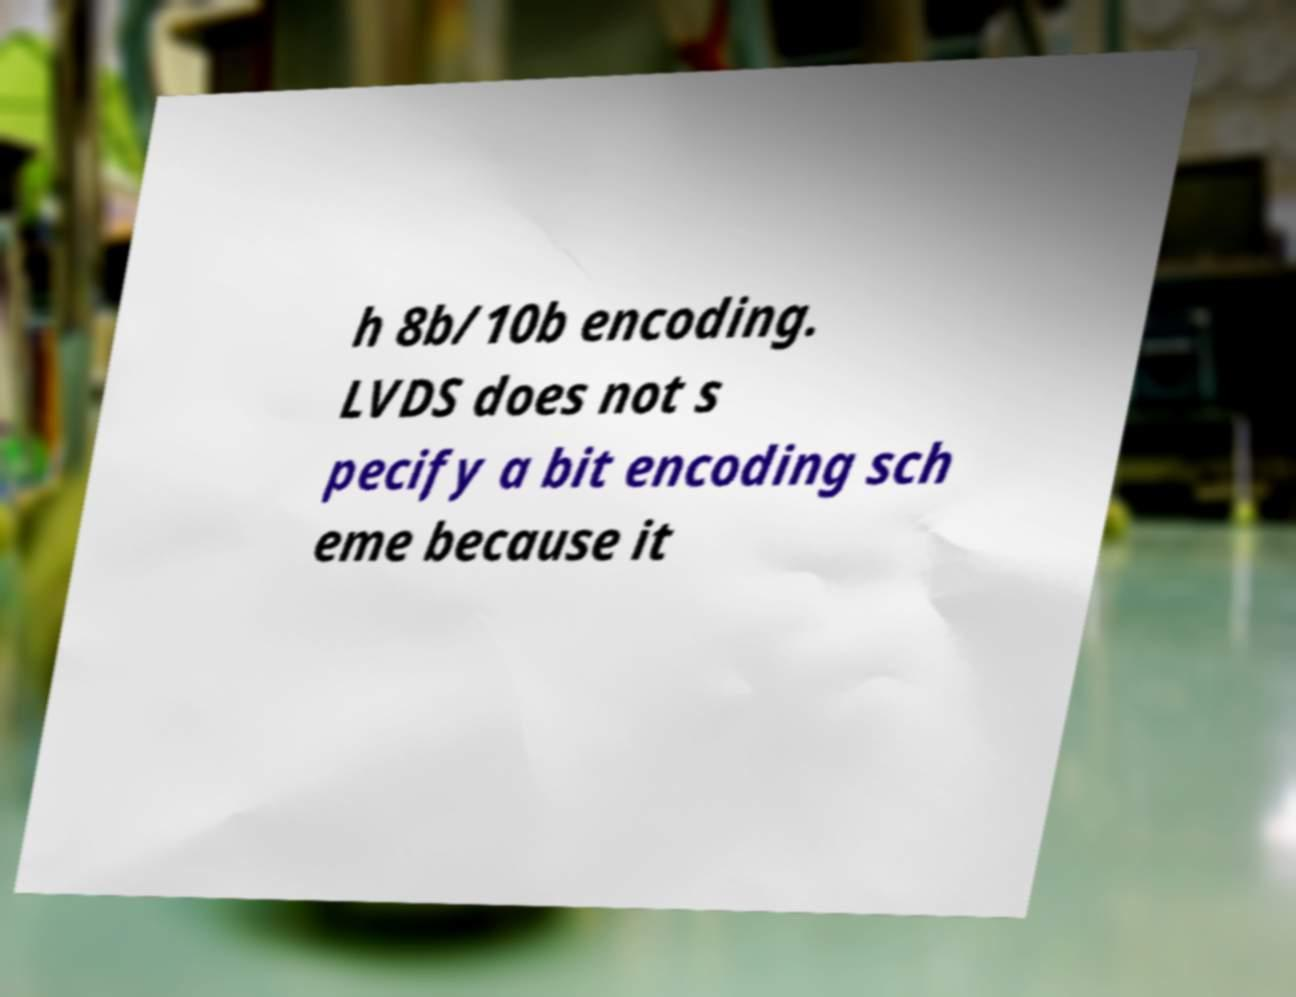What messages or text are displayed in this image? I need them in a readable, typed format. h 8b/10b encoding. LVDS does not s pecify a bit encoding sch eme because it 